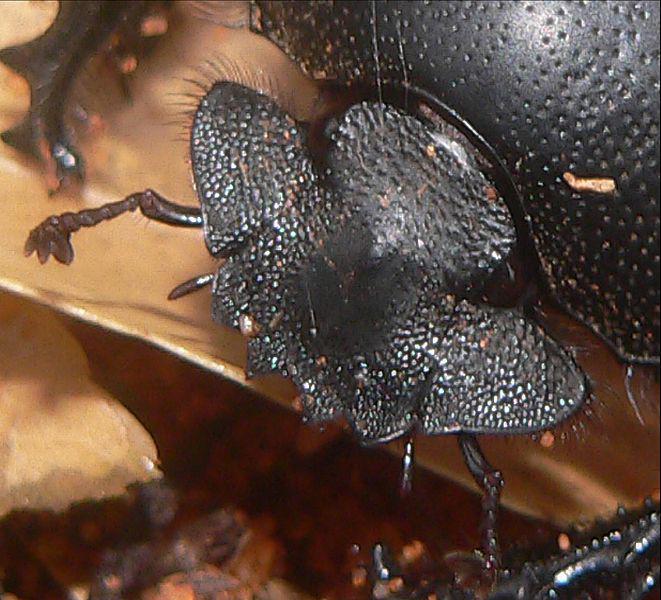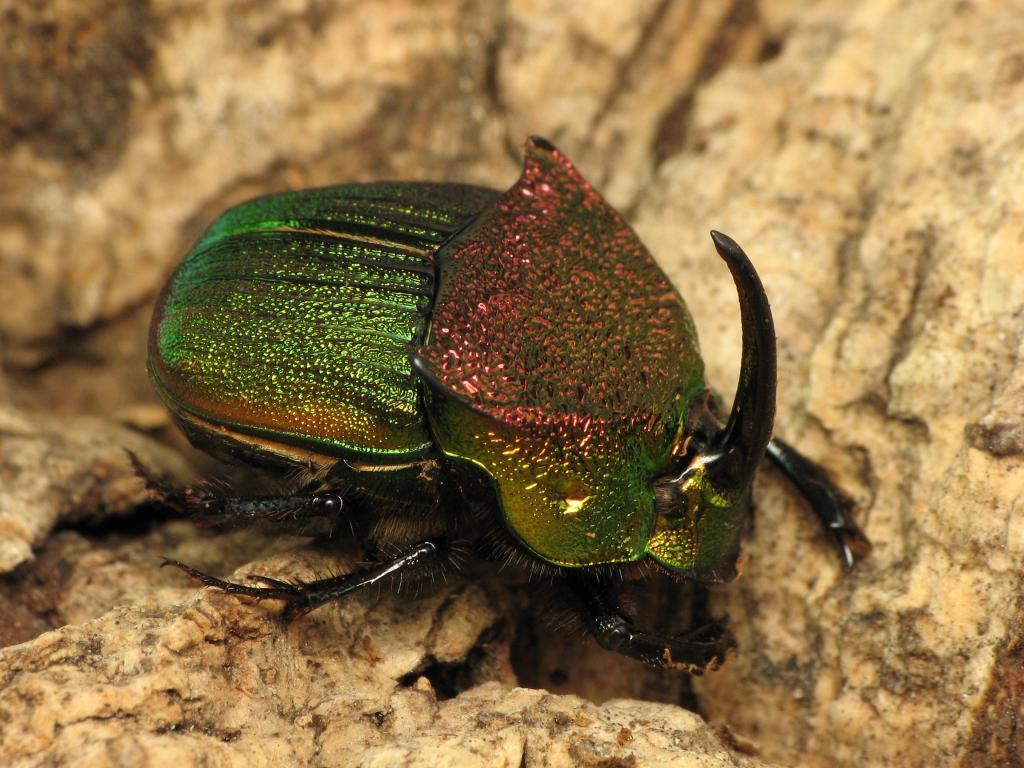The first image is the image on the left, the second image is the image on the right. Analyze the images presented: Is the assertion "Each image includes a beetle in contact with a round dung ball." valid? Answer yes or no. No. The first image is the image on the left, the second image is the image on the right. For the images displayed, is the sentence "A beetle is on a dung ball." factually correct? Answer yes or no. No. 